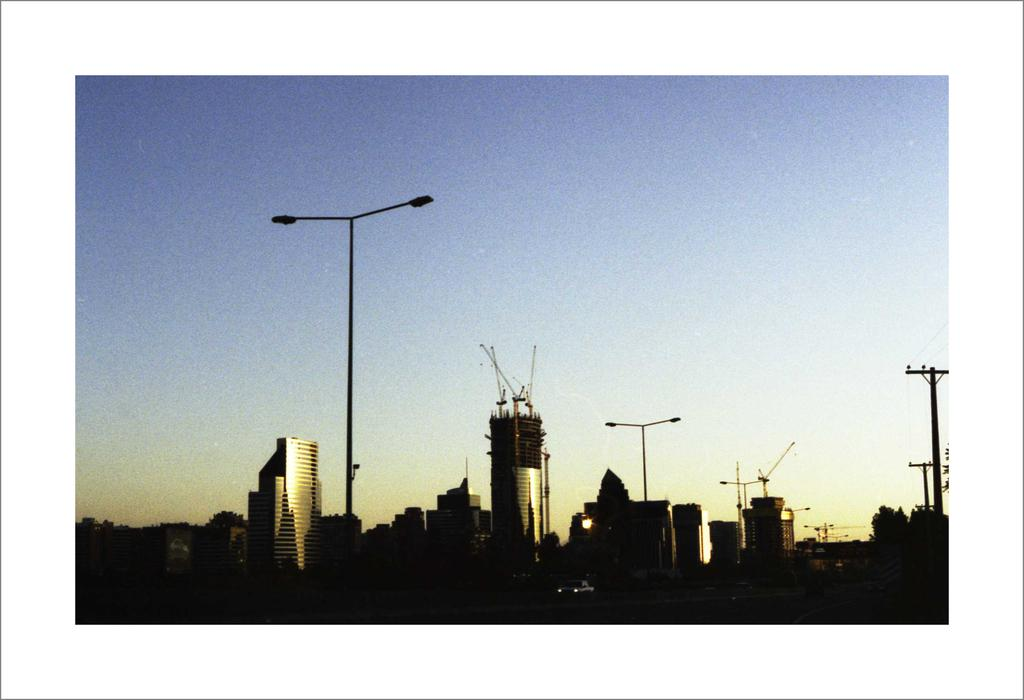What type of structures can be seen in the image? There are buildings in the image. What else is present in the image besides the buildings? There are poles in the image. What color is the sky in the image? The sky is blue in color. Can you see any sand in the image? There is no sand present in the image. What type of chalk is being used to draw on the buildings in the image? There is no chalk or drawing on the buildings in the image. 